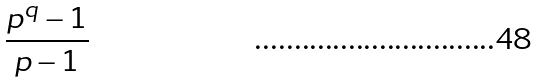Convert formula to latex. <formula><loc_0><loc_0><loc_500><loc_500>\frac { p ^ { q } - 1 } { p - 1 }</formula> 